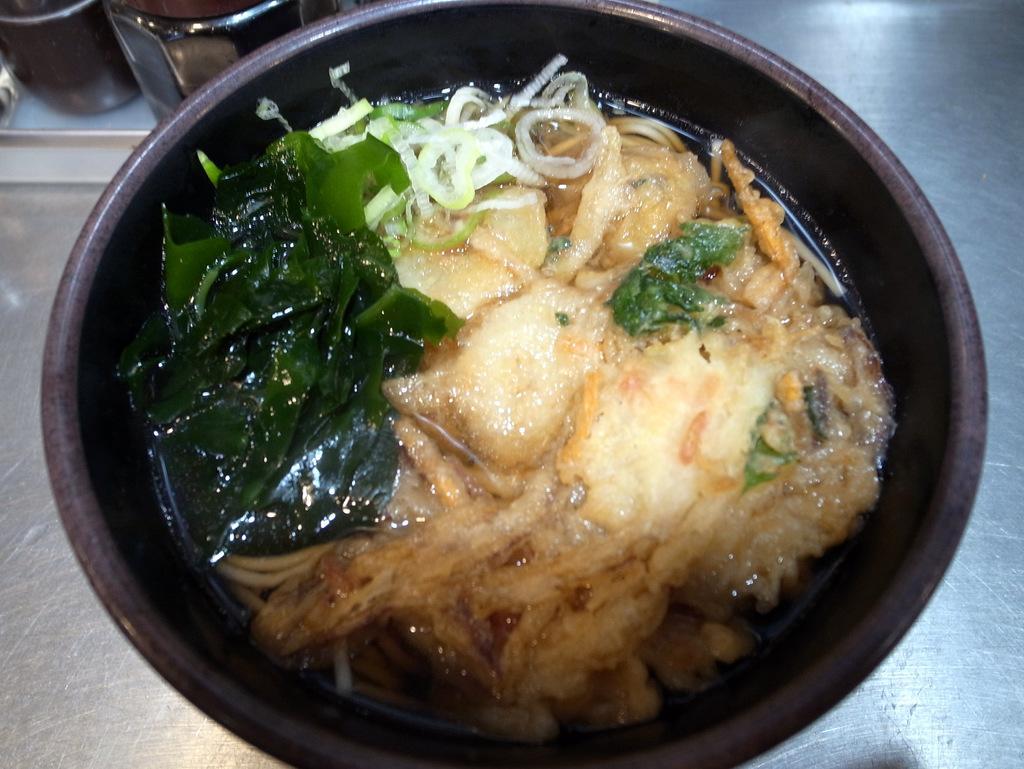Please provide a concise description of this image. The picture consists of a pan, in the pan there is a food item. On the left there are jars. At the bottom it is an iron object. 